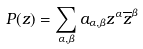Convert formula to latex. <formula><loc_0><loc_0><loc_500><loc_500>P ( z ) = \sum _ { \alpha , \beta } a _ { \alpha , \beta } z ^ { \alpha } \overline { z } ^ { \beta }</formula> 